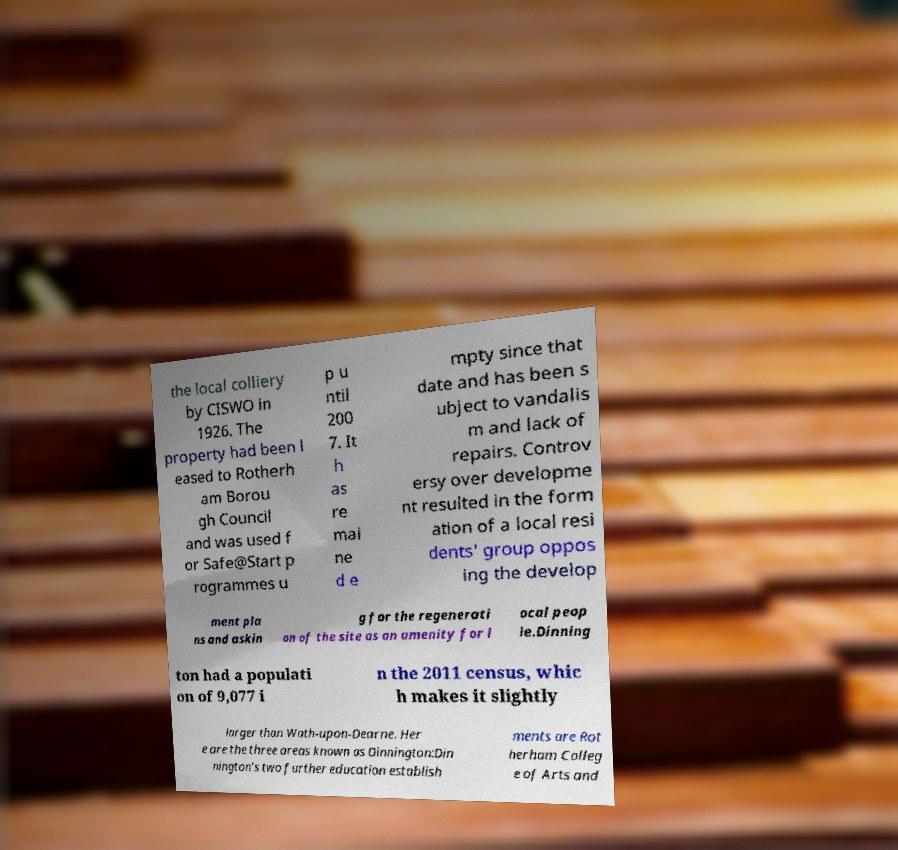Could you assist in decoding the text presented in this image and type it out clearly? the local colliery by CISWO in 1926. The property had been l eased to Rotherh am Borou gh Council and was used f or Safe@Start p rogrammes u p u ntil 200 7. It h as re mai ne d e mpty since that date and has been s ubject to vandalis m and lack of repairs. Controv ersy over developme nt resulted in the form ation of a local resi dents' group oppos ing the develop ment pla ns and askin g for the regenerati on of the site as an amenity for l ocal peop le.Dinning ton had a populati on of 9,077 i n the 2011 census, whic h makes it slightly larger than Wath-upon-Dearne. Her e are the three areas known as Dinnington:Din nington's two further education establish ments are Rot herham Colleg e of Arts and 